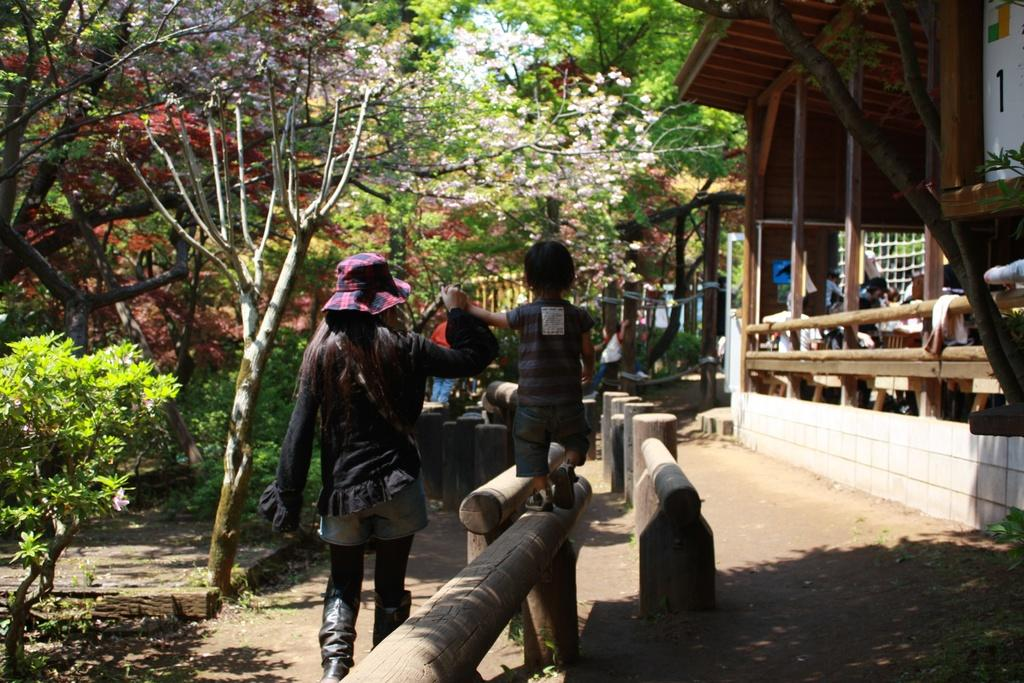What is the main subject of the image? A woman is walking in the middle of the image. What is the woman doing in the image? The woman is helping a baby to walk. Can you describe the woman's attire? The woman is wearing a hat. What can be seen on the left side of the image? There are trees on the left side of the image. What type of structure is visible on the right side of the image? There is a wooden house on the right side of the image. How does the woman control the baby's movements in the image? The image does not show the woman controlling the baby's movements; she is helping the baby to walk. Is there a cellar visible in the image? There is no mention of a cellar in the provided facts, and it is not visible in the image. 